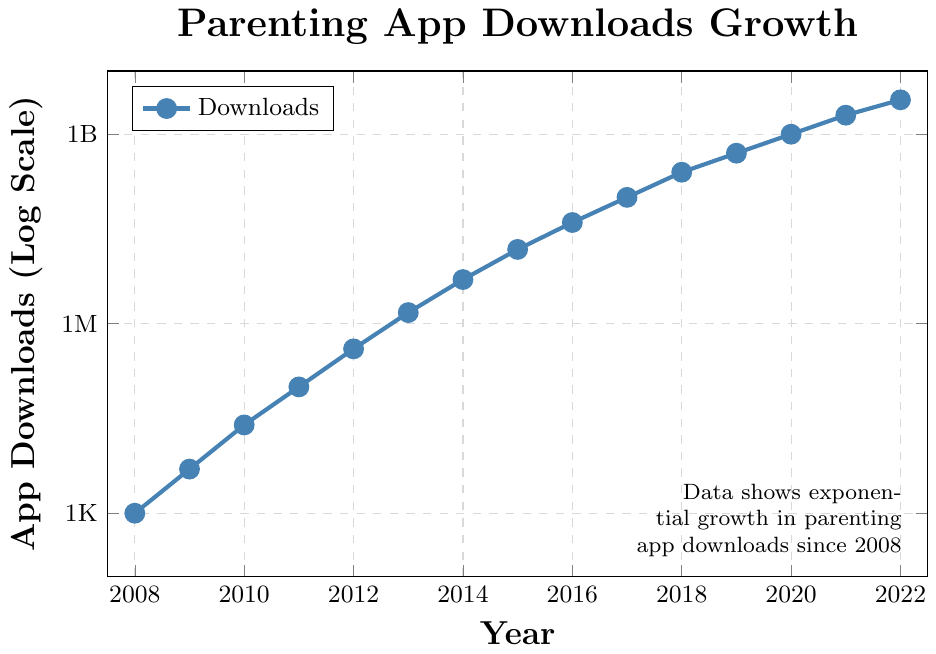How many times greater were app downloads in 2022 compared to 2008? To find how many times greater the downloads were in 2022 compared to 2008, we divide the downloads in 2022 by the downloads in 2008. The number of downloads in 2022 is 3,500,000,000 and in 2008 is 1,000. So, 3,500,000,000 ÷ 1,000 = 3,500,000.
Answer: 3,500,000 What is the approximate growth rate in app downloads between 2015 and 2016? To calculate the approximate growth rate, we take the downloads in 2016, subtract the downloads in 2015, then divide by the downloads in 2015. From the figure, the downloads in 2016 are 40,000,000 and in 2015 are 15,000,000. So, (40,000,000 - 15,000,000) / 15,000,000 = 1.67, which is approximately 167%.
Answer: 167% Between which consecutive years did the app downloads increase the most? To determine this, we inspect the year-on-year changes shown on the plot. The highest visible increase seems to occur between 2020 and 2021, where downloads grow from 1,000,000,000 to 2,000,000,000. The increase is 1,000,000,000.
Answer: 2020 and 2021 By what factor did the app downloads increase from 2018 to 2020? To find the factor by which the downloads increased, we divide the downloads in 2020 by the downloads in 2018. The downloads in 2020 are 1,000,000,000 and in 2018 are 250,000,000. Therefore, 1,000,000,000 ÷ 250,000,000 = 4.
Answer: 4 Is there a year where app downloads quadrupled compared to the previous year? If so, which year is it? We need to check if the downloads in any given year are approximately four times the downloads in the previous year. Between 2014 (5,000,000) and 2015 (15,000,000), the downloads appear to triple. However, between 2015 (15,000,000) and 2016 (40,000,000), they do not quite quadruple. The exact quadrupling occurs between 2019 (500,000,000) and 2020 (1,000,000,000).
Answer: 2020 What is the color of the line representing app downloads? The visual attribute of the line color used to represent app downloads must be identified. The plot shows the line in blue color.
Answer: Blue 